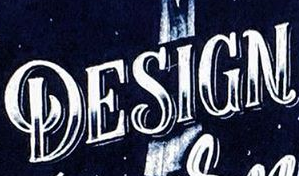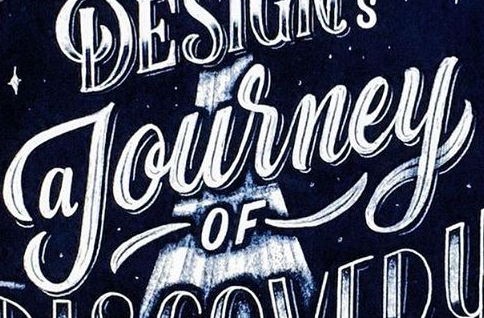What text is displayed in these images sequentially, separated by a semicolon? DESIGN; Journey 